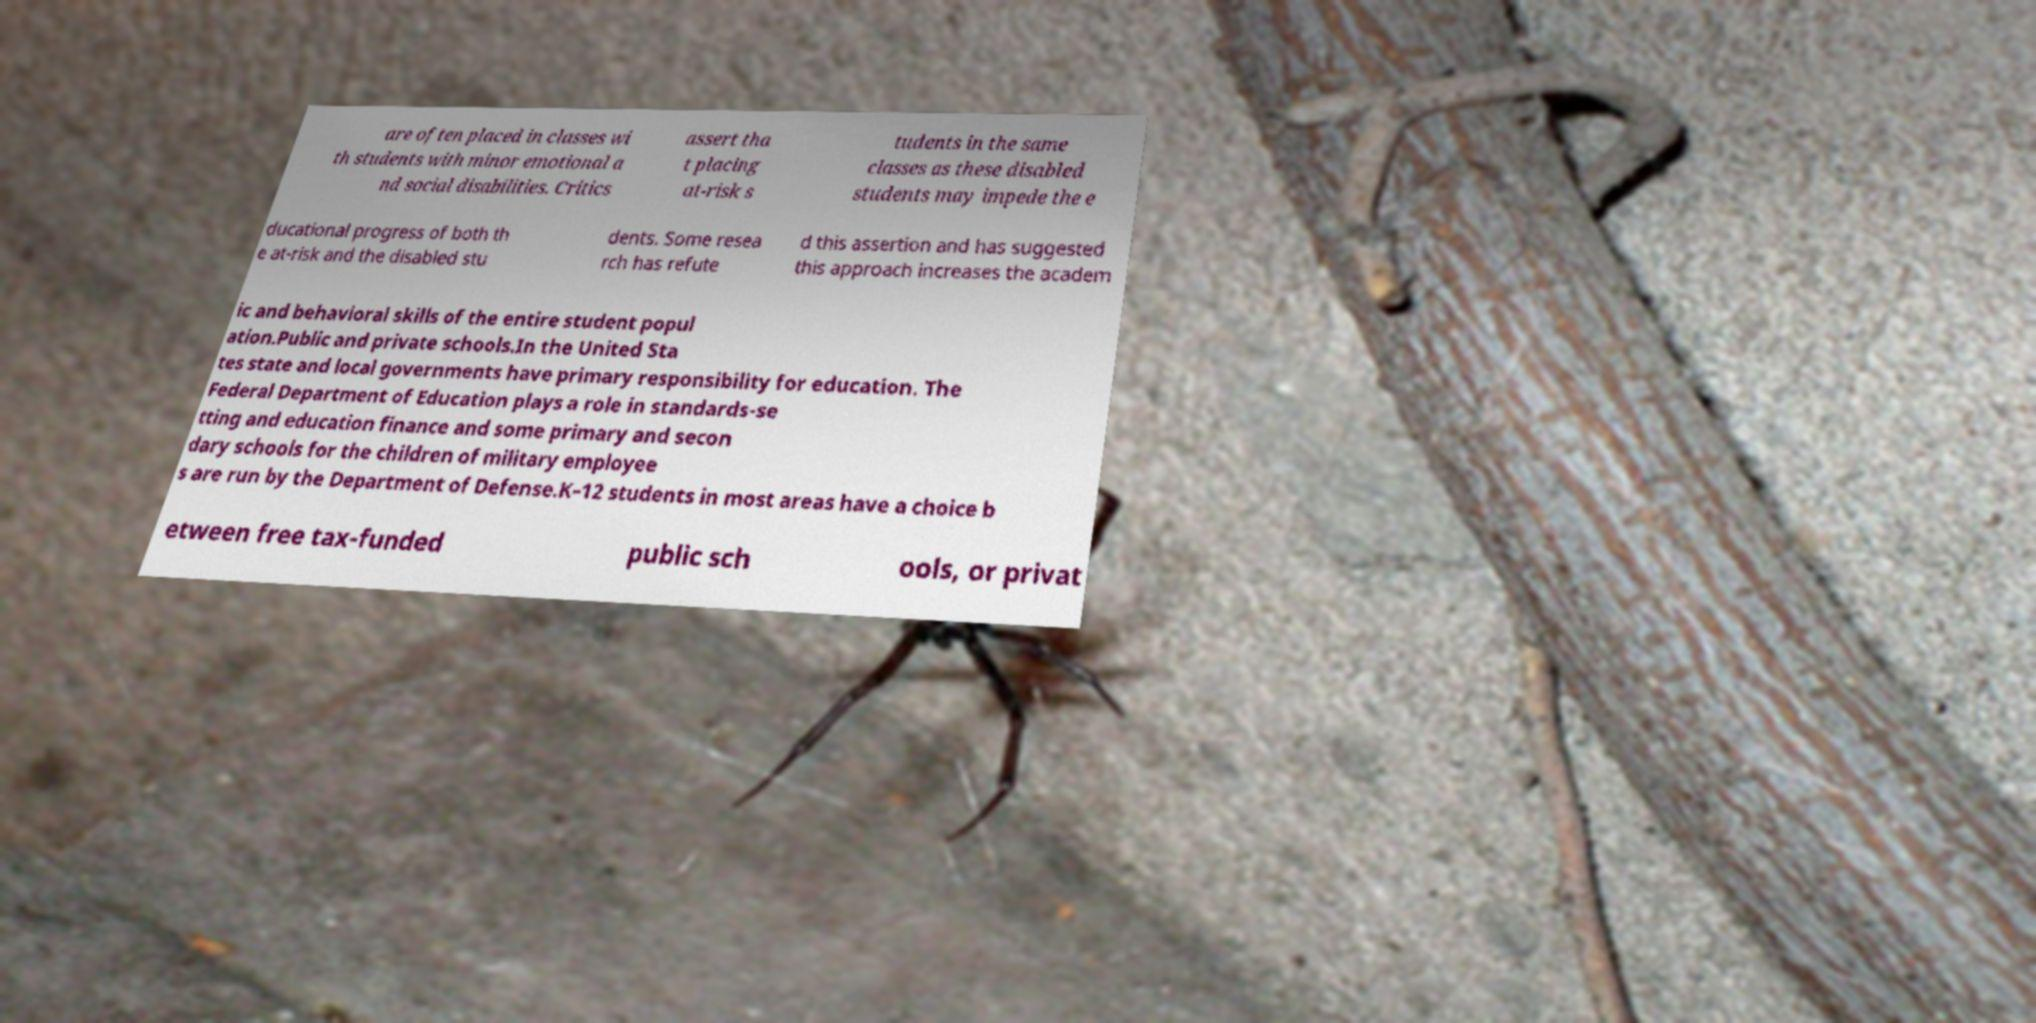For documentation purposes, I need the text within this image transcribed. Could you provide that? are often placed in classes wi th students with minor emotional a nd social disabilities. Critics assert tha t placing at-risk s tudents in the same classes as these disabled students may impede the e ducational progress of both th e at-risk and the disabled stu dents. Some resea rch has refute d this assertion and has suggested this approach increases the academ ic and behavioral skills of the entire student popul ation.Public and private schools.In the United Sta tes state and local governments have primary responsibility for education. The Federal Department of Education plays a role in standards-se tting and education finance and some primary and secon dary schools for the children of military employee s are run by the Department of Defense.K–12 students in most areas have a choice b etween free tax-funded public sch ools, or privat 